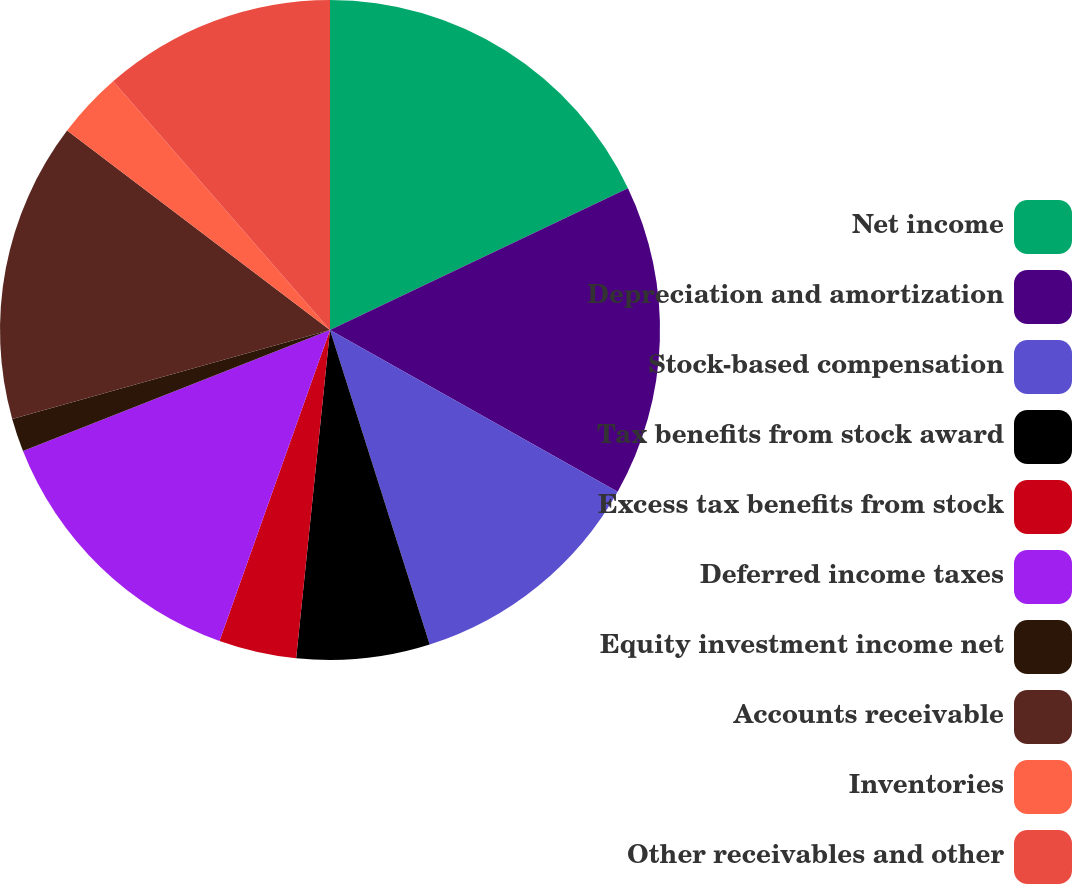Convert chart. <chart><loc_0><loc_0><loc_500><loc_500><pie_chart><fcel>Net income<fcel>Depreciation and amortization<fcel>Stock-based compensation<fcel>Tax benefits from stock award<fcel>Excess tax benefits from stock<fcel>Deferred income taxes<fcel>Equity investment income net<fcel>Accounts receivable<fcel>Inventories<fcel>Other receivables and other<nl><fcel>17.93%<fcel>15.22%<fcel>11.96%<fcel>6.52%<fcel>3.8%<fcel>13.59%<fcel>1.63%<fcel>14.67%<fcel>3.26%<fcel>11.41%<nl></chart> 